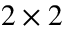<formula> <loc_0><loc_0><loc_500><loc_500>2 \times 2</formula> 